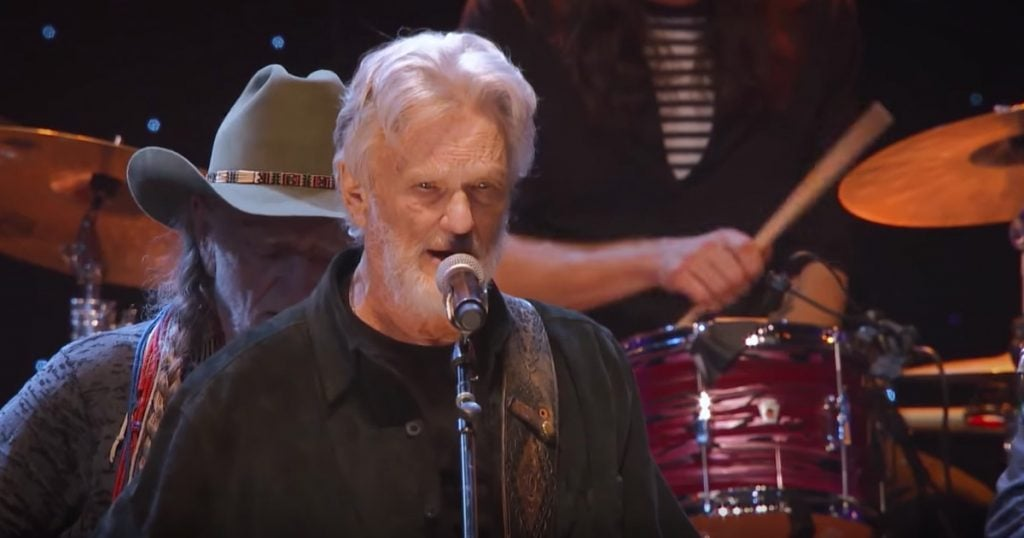Describe a realistic short response scenario reflecting a typical performance of the musicians in the image. In a typical performance, the musicians perform at a cozy, dimly lit venue filled with dedicated fans. They deliver a soulful set of traditional country and folk songs, with the audience singing along to familiar tunes. The intimate atmosphere brings out the raw emotion in their music, creating a memorable experience for everyone present. 